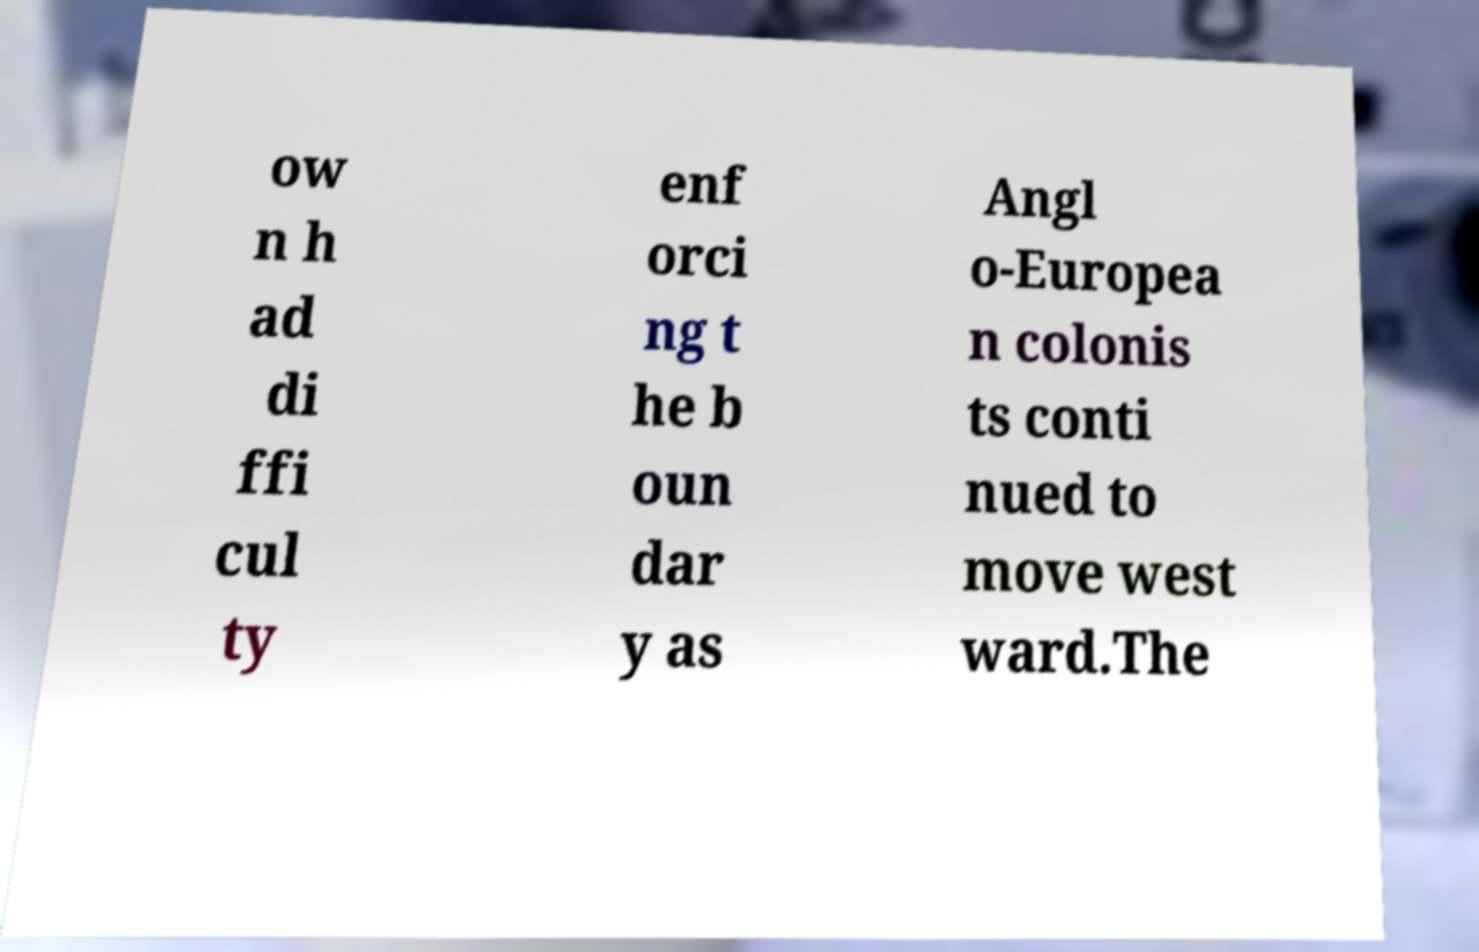Could you assist in decoding the text presented in this image and type it out clearly? ow n h ad di ffi cul ty enf orci ng t he b oun dar y as Angl o-Europea n colonis ts conti nued to move west ward.The 